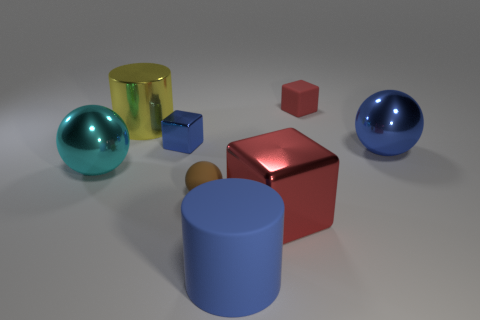There is a tiny metal object that is the same color as the matte cylinder; what shape is it?
Give a very brief answer. Cube. The shiny ball that is left of the large blue thing behind the brown thing is what color?
Ensure brevity in your answer.  Cyan. Are there more tiny brown things that are in front of the small brown thing than matte things on the left side of the tiny red matte block?
Your response must be concise. No. Are the red thing in front of the cyan metal ball and the large blue cylinder that is right of the rubber ball made of the same material?
Your answer should be compact. No. There is a brown rubber ball; are there any big red things in front of it?
Offer a terse response. Yes. How many yellow things are shiny cylinders or small matte balls?
Provide a short and direct response. 1. Is the material of the big block the same as the large ball that is right of the matte cube?
Your response must be concise. Yes. There is a blue thing that is the same shape as the red matte thing; what is its size?
Give a very brief answer. Small. What is the large cyan ball made of?
Your response must be concise. Metal. What is the block that is behind the small blue metal cube that is to the right of the big ball to the left of the small brown rubber sphere made of?
Offer a terse response. Rubber. 